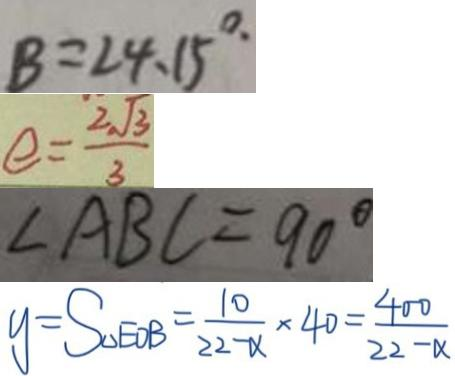<formula> <loc_0><loc_0><loc_500><loc_500>B = 2 4 . 1 5 ^ { \circ . } 
 e = \frac { 2 \sqrt { 3 } } { 3 } 
 \angle A B C = 9 0 ^ { \circ } 
 y = S _ { \Delta E B } = \frac { 1 0 } { 2 2 - \alpha } \times 4 0 = \frac { 4 0 0 } { 2 2 - \alpha }</formula> 